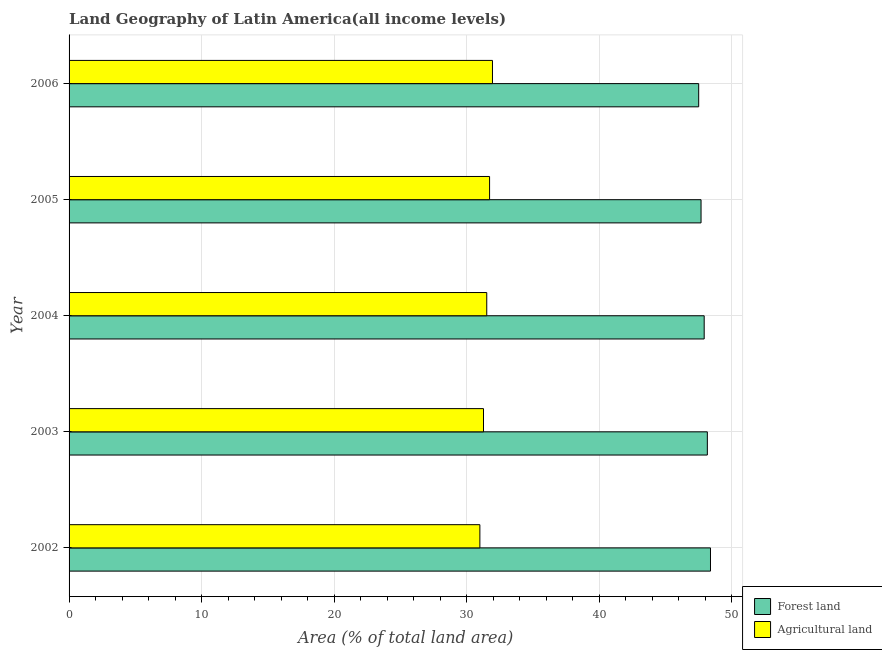How many groups of bars are there?
Give a very brief answer. 5. Are the number of bars on each tick of the Y-axis equal?
Keep it short and to the point. Yes. How many bars are there on the 5th tick from the top?
Your answer should be very brief. 2. What is the percentage of land area under agriculture in 2002?
Provide a succinct answer. 31.01. Across all years, what is the maximum percentage of land area under agriculture?
Give a very brief answer. 31.96. Across all years, what is the minimum percentage of land area under forests?
Make the answer very short. 47.52. In which year was the percentage of land area under forests maximum?
Your answer should be very brief. 2002. What is the total percentage of land area under forests in the graph?
Your answer should be very brief. 239.74. What is the difference between the percentage of land area under agriculture in 2005 and that in 2006?
Offer a terse response. -0.22. What is the difference between the percentage of land area under forests in 2004 and the percentage of land area under agriculture in 2005?
Provide a short and direct response. 16.2. What is the average percentage of land area under agriculture per year?
Provide a succinct answer. 31.5. In the year 2002, what is the difference between the percentage of land area under forests and percentage of land area under agriculture?
Offer a terse response. 17.41. What is the ratio of the percentage of land area under agriculture in 2002 to that in 2003?
Give a very brief answer. 0.99. Is the percentage of land area under agriculture in 2003 less than that in 2006?
Give a very brief answer. Yes. What is the difference between the highest and the second highest percentage of land area under agriculture?
Provide a succinct answer. 0.22. What is the difference between the highest and the lowest percentage of land area under forests?
Provide a short and direct response. 0.89. In how many years, is the percentage of land area under agriculture greater than the average percentage of land area under agriculture taken over all years?
Provide a succinct answer. 3. What does the 2nd bar from the top in 2004 represents?
Your response must be concise. Forest land. What does the 1st bar from the bottom in 2004 represents?
Offer a terse response. Forest land. How many bars are there?
Offer a terse response. 10. Are all the bars in the graph horizontal?
Give a very brief answer. Yes. What is the difference between two consecutive major ticks on the X-axis?
Offer a terse response. 10. Are the values on the major ticks of X-axis written in scientific E-notation?
Offer a terse response. No. Does the graph contain grids?
Offer a very short reply. Yes. How are the legend labels stacked?
Provide a succinct answer. Vertical. What is the title of the graph?
Your answer should be very brief. Land Geography of Latin America(all income levels). Does "Banks" appear as one of the legend labels in the graph?
Provide a short and direct response. No. What is the label or title of the X-axis?
Provide a succinct answer. Area (% of total land area). What is the Area (% of total land area) of Forest land in 2002?
Provide a succinct answer. 48.41. What is the Area (% of total land area) of Agricultural land in 2002?
Provide a succinct answer. 31.01. What is the Area (% of total land area) of Forest land in 2003?
Your answer should be very brief. 48.17. What is the Area (% of total land area) of Agricultural land in 2003?
Ensure brevity in your answer.  31.28. What is the Area (% of total land area) of Forest land in 2004?
Make the answer very short. 47.94. What is the Area (% of total land area) in Agricultural land in 2004?
Your answer should be very brief. 31.52. What is the Area (% of total land area) in Forest land in 2005?
Ensure brevity in your answer.  47.7. What is the Area (% of total land area) in Agricultural land in 2005?
Offer a very short reply. 31.74. What is the Area (% of total land area) of Forest land in 2006?
Make the answer very short. 47.52. What is the Area (% of total land area) in Agricultural land in 2006?
Provide a succinct answer. 31.96. Across all years, what is the maximum Area (% of total land area) in Forest land?
Your response must be concise. 48.41. Across all years, what is the maximum Area (% of total land area) of Agricultural land?
Your answer should be very brief. 31.96. Across all years, what is the minimum Area (% of total land area) of Forest land?
Your answer should be compact. 47.52. Across all years, what is the minimum Area (% of total land area) in Agricultural land?
Give a very brief answer. 31.01. What is the total Area (% of total land area) in Forest land in the graph?
Your answer should be very brief. 239.74. What is the total Area (% of total land area) of Agricultural land in the graph?
Offer a very short reply. 157.5. What is the difference between the Area (% of total land area) in Forest land in 2002 and that in 2003?
Ensure brevity in your answer.  0.24. What is the difference between the Area (% of total land area) in Agricultural land in 2002 and that in 2003?
Give a very brief answer. -0.27. What is the difference between the Area (% of total land area) in Forest land in 2002 and that in 2004?
Your answer should be compact. 0.47. What is the difference between the Area (% of total land area) in Agricultural land in 2002 and that in 2004?
Keep it short and to the point. -0.52. What is the difference between the Area (% of total land area) of Forest land in 2002 and that in 2005?
Give a very brief answer. 0.71. What is the difference between the Area (% of total land area) of Agricultural land in 2002 and that in 2005?
Offer a terse response. -0.73. What is the difference between the Area (% of total land area) of Forest land in 2002 and that in 2006?
Offer a very short reply. 0.89. What is the difference between the Area (% of total land area) in Agricultural land in 2002 and that in 2006?
Give a very brief answer. -0.95. What is the difference between the Area (% of total land area) in Forest land in 2003 and that in 2004?
Offer a very short reply. 0.24. What is the difference between the Area (% of total land area) of Agricultural land in 2003 and that in 2004?
Ensure brevity in your answer.  -0.25. What is the difference between the Area (% of total land area) in Forest land in 2003 and that in 2005?
Your response must be concise. 0.47. What is the difference between the Area (% of total land area) in Agricultural land in 2003 and that in 2005?
Ensure brevity in your answer.  -0.46. What is the difference between the Area (% of total land area) of Forest land in 2003 and that in 2006?
Keep it short and to the point. 0.65. What is the difference between the Area (% of total land area) in Agricultural land in 2003 and that in 2006?
Your answer should be compact. -0.68. What is the difference between the Area (% of total land area) of Forest land in 2004 and that in 2005?
Ensure brevity in your answer.  0.24. What is the difference between the Area (% of total land area) of Agricultural land in 2004 and that in 2005?
Provide a succinct answer. -0.21. What is the difference between the Area (% of total land area) of Forest land in 2004 and that in 2006?
Offer a terse response. 0.42. What is the difference between the Area (% of total land area) in Agricultural land in 2004 and that in 2006?
Provide a succinct answer. -0.43. What is the difference between the Area (% of total land area) of Forest land in 2005 and that in 2006?
Provide a succinct answer. 0.18. What is the difference between the Area (% of total land area) of Agricultural land in 2005 and that in 2006?
Give a very brief answer. -0.22. What is the difference between the Area (% of total land area) of Forest land in 2002 and the Area (% of total land area) of Agricultural land in 2003?
Your response must be concise. 17.13. What is the difference between the Area (% of total land area) in Forest land in 2002 and the Area (% of total land area) in Agricultural land in 2004?
Give a very brief answer. 16.89. What is the difference between the Area (% of total land area) of Forest land in 2002 and the Area (% of total land area) of Agricultural land in 2005?
Provide a succinct answer. 16.67. What is the difference between the Area (% of total land area) of Forest land in 2002 and the Area (% of total land area) of Agricultural land in 2006?
Your response must be concise. 16.45. What is the difference between the Area (% of total land area) in Forest land in 2003 and the Area (% of total land area) in Agricultural land in 2004?
Provide a short and direct response. 16.65. What is the difference between the Area (% of total land area) of Forest land in 2003 and the Area (% of total land area) of Agricultural land in 2005?
Give a very brief answer. 16.44. What is the difference between the Area (% of total land area) in Forest land in 2003 and the Area (% of total land area) in Agricultural land in 2006?
Your response must be concise. 16.22. What is the difference between the Area (% of total land area) of Forest land in 2004 and the Area (% of total land area) of Agricultural land in 2005?
Provide a short and direct response. 16.2. What is the difference between the Area (% of total land area) in Forest land in 2004 and the Area (% of total land area) in Agricultural land in 2006?
Ensure brevity in your answer.  15.98. What is the difference between the Area (% of total land area) in Forest land in 2005 and the Area (% of total land area) in Agricultural land in 2006?
Your answer should be very brief. 15.74. What is the average Area (% of total land area) of Forest land per year?
Offer a terse response. 47.95. What is the average Area (% of total land area) of Agricultural land per year?
Provide a short and direct response. 31.5. In the year 2002, what is the difference between the Area (% of total land area) in Forest land and Area (% of total land area) in Agricultural land?
Provide a short and direct response. 17.4. In the year 2003, what is the difference between the Area (% of total land area) of Forest land and Area (% of total land area) of Agricultural land?
Offer a very short reply. 16.89. In the year 2004, what is the difference between the Area (% of total land area) in Forest land and Area (% of total land area) in Agricultural land?
Make the answer very short. 16.41. In the year 2005, what is the difference between the Area (% of total land area) in Forest land and Area (% of total land area) in Agricultural land?
Provide a short and direct response. 15.96. In the year 2006, what is the difference between the Area (% of total land area) of Forest land and Area (% of total land area) of Agricultural land?
Keep it short and to the point. 15.56. What is the ratio of the Area (% of total land area) of Forest land in 2002 to that in 2003?
Offer a terse response. 1. What is the ratio of the Area (% of total land area) of Agricultural land in 2002 to that in 2003?
Make the answer very short. 0.99. What is the ratio of the Area (% of total land area) of Forest land in 2002 to that in 2004?
Give a very brief answer. 1.01. What is the ratio of the Area (% of total land area) in Agricultural land in 2002 to that in 2004?
Your answer should be very brief. 0.98. What is the ratio of the Area (% of total land area) of Forest land in 2002 to that in 2005?
Offer a very short reply. 1.01. What is the ratio of the Area (% of total land area) of Forest land in 2002 to that in 2006?
Provide a short and direct response. 1.02. What is the ratio of the Area (% of total land area) in Agricultural land in 2002 to that in 2006?
Make the answer very short. 0.97. What is the ratio of the Area (% of total land area) of Agricultural land in 2003 to that in 2004?
Offer a very short reply. 0.99. What is the ratio of the Area (% of total land area) of Forest land in 2003 to that in 2005?
Ensure brevity in your answer.  1.01. What is the ratio of the Area (% of total land area) in Agricultural land in 2003 to that in 2005?
Your answer should be very brief. 0.99. What is the ratio of the Area (% of total land area) of Forest land in 2003 to that in 2006?
Your response must be concise. 1.01. What is the ratio of the Area (% of total land area) of Agricultural land in 2003 to that in 2006?
Provide a succinct answer. 0.98. What is the ratio of the Area (% of total land area) in Forest land in 2004 to that in 2006?
Your answer should be compact. 1.01. What is the ratio of the Area (% of total land area) of Agricultural land in 2004 to that in 2006?
Your answer should be very brief. 0.99. What is the ratio of the Area (% of total land area) in Agricultural land in 2005 to that in 2006?
Your response must be concise. 0.99. What is the difference between the highest and the second highest Area (% of total land area) of Forest land?
Provide a succinct answer. 0.24. What is the difference between the highest and the second highest Area (% of total land area) of Agricultural land?
Ensure brevity in your answer.  0.22. What is the difference between the highest and the lowest Area (% of total land area) of Forest land?
Give a very brief answer. 0.89. What is the difference between the highest and the lowest Area (% of total land area) of Agricultural land?
Offer a terse response. 0.95. 